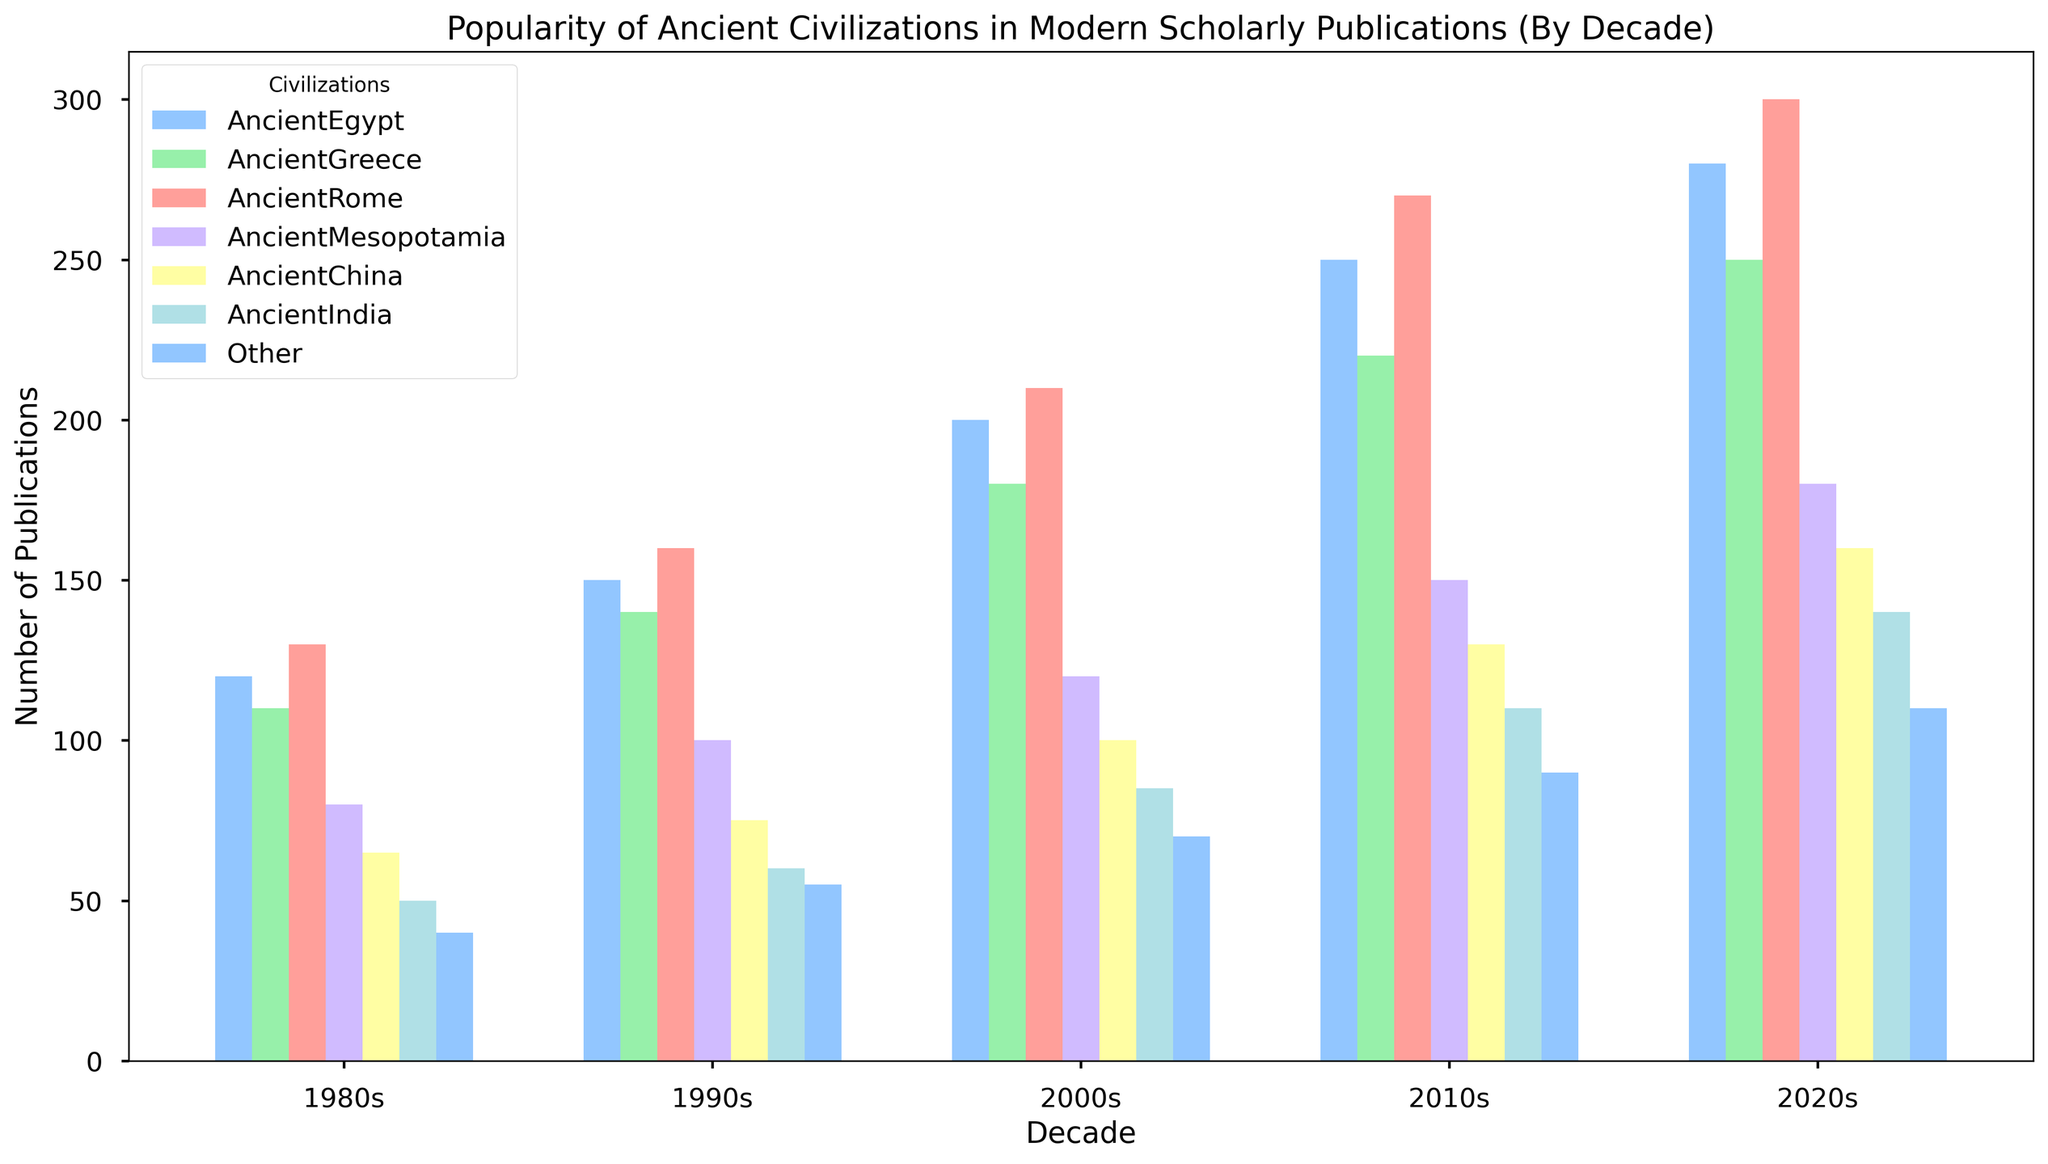Which civilization had the highest number of publications in the 2020s? Look for the tallest bar in the 2020s group and match its color to the legend.
Answer: Ancient Rome What's the total number of publications for Ancient Greece across all decades? Sum the values for Ancient Greece from each decade: 110 (1980s) + 140 (1990s) + 180 (2000s) + 220 (2010s) + 250 (2020s) = 900
Answer: 900 How did the popularity of Ancient Mesopotamia change from the 1980s to the 2020s? Compare the height of the bars for Ancient Mesopotamia in the 1980s and 2020s.
Answer: Increased Which two civilizations had the closest number of publications in the 2010s? Compare the heights of the bars for the 2010s and identify the two with the smallest difference.
Answer: Ancient China and Ancient India During which decade did Ancient Egypt see the largest increase in publications compared to the previous decade? Calculate the differences between consecutive decades for Ancient Egypt: 150-120=30 (1980s-1990s), 200-150=50 (1990s-2000s), 250-200=50 (2000s-2010s), 280-250=30 (2010s-2020s).
Answer: 2000s Which civilization shows a consistent increase in the number of publications each decade? Check each civilization's bar heights from the 1980s to the 2020s for a steady upward trend.
Answer: All civilizations What's the average number of publications for Ancient China across all decades? Sum the values for Ancient China and divide by the number of decades: (65 + 75 + 100 + 130 + 160) / 5 = 530 / 5 = 106
Answer: 106 Which decades had an equal number of publications for "Other" civilizations? Compare the heights of the "Other" civilization bars across decades.
Answer: None In which decade was the gap between Ancient Rome and Ancient Greece publications the largest? Calculate the differences for each decade and identify the maximum: 
1980s: 130-110=20, 
1990s: 160-140=20, 
2000s: 210-180=30, 
2010s: 270-220=50, 
2020s: 300-250=50
Answer: 2010s and 2020s How many more publications did Ancient China have in the 2020s compared to the 1980s? Subtract the 1980s value from the 2020s value for Ancient China: 160-65 = 95
Answer: 95 